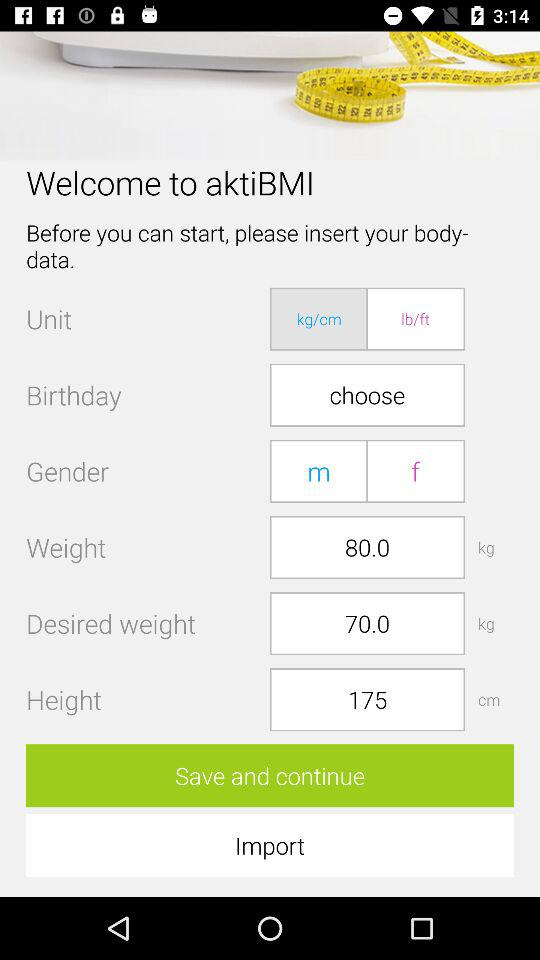What is the height? The height is 175 cm. 